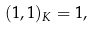Convert formula to latex. <formula><loc_0><loc_0><loc_500><loc_500>( 1 , 1 ) _ { K } = 1 ,</formula> 